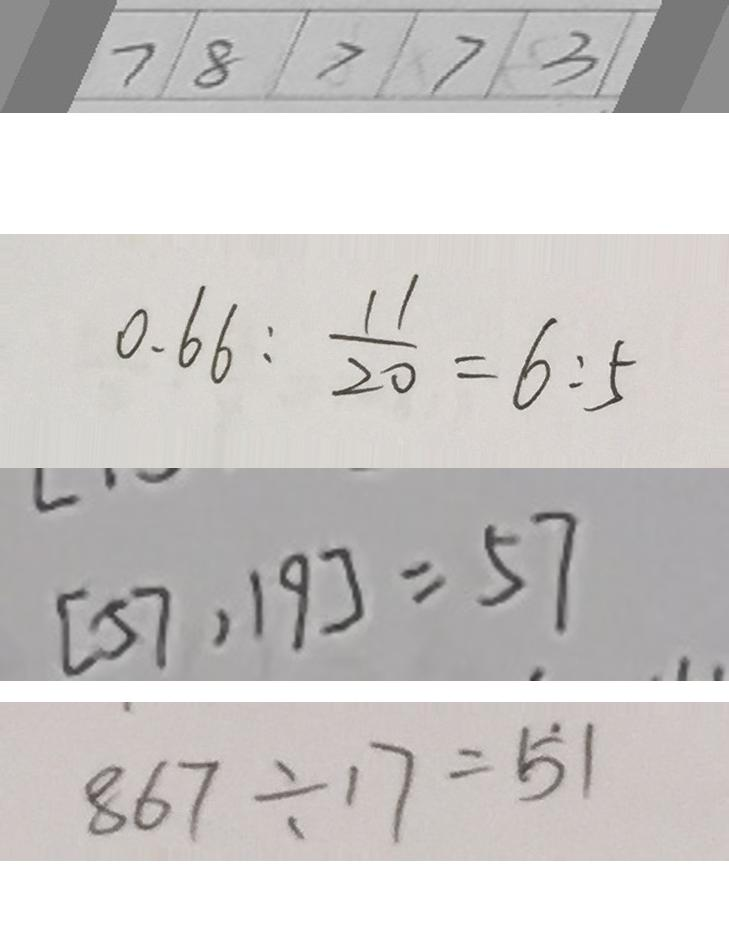Convert formula to latex. <formula><loc_0><loc_0><loc_500><loc_500>\boxed { 7 } \boxed { 8 } \boxed { > } \boxed { 7 } \boxed { 3 } 
 0 . 6 6 : \frac { 1 1 } { 2 0 } = 6 : 5 
 [ 5 7 , 1 9 ] = 5 7 
 8 6 7 \div 1 7 = \dot { 5 } 1</formula> 